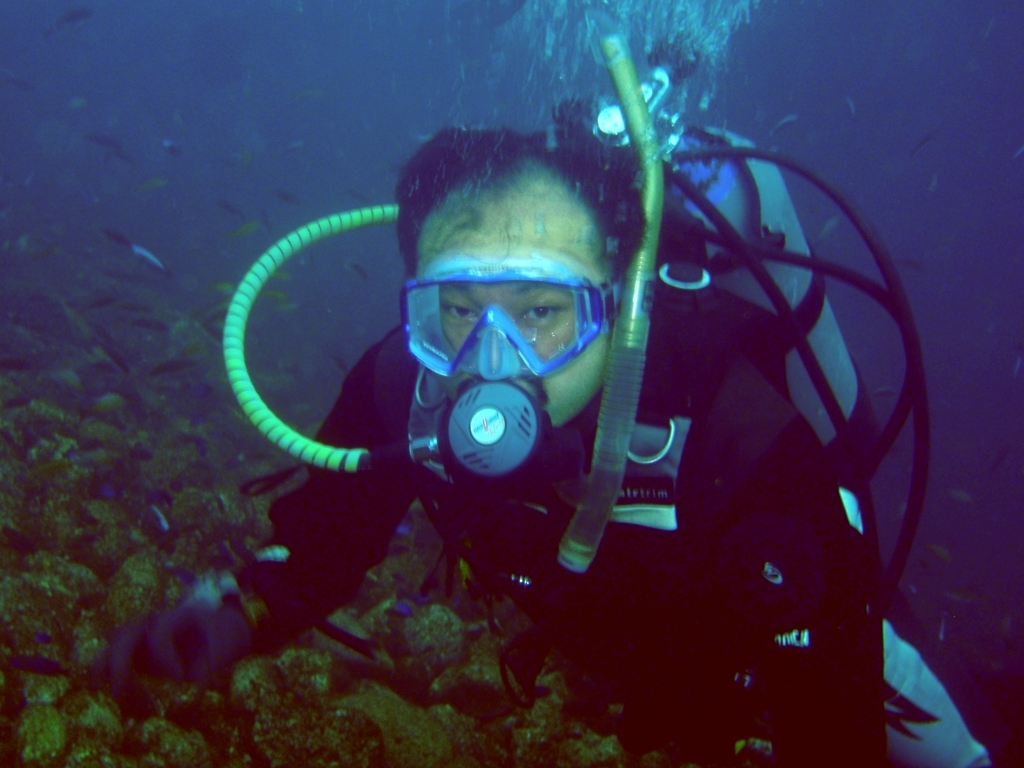Which color tone does this photo primarily lean towards?
A. Yellow
B. Blue
C. Red The prevalent color tone in the photo is blue, likely due to the underwater environment which naturally filters out the warmer parts of the light spectrum, thus giving an immersive, serene blue hue to the scene. 